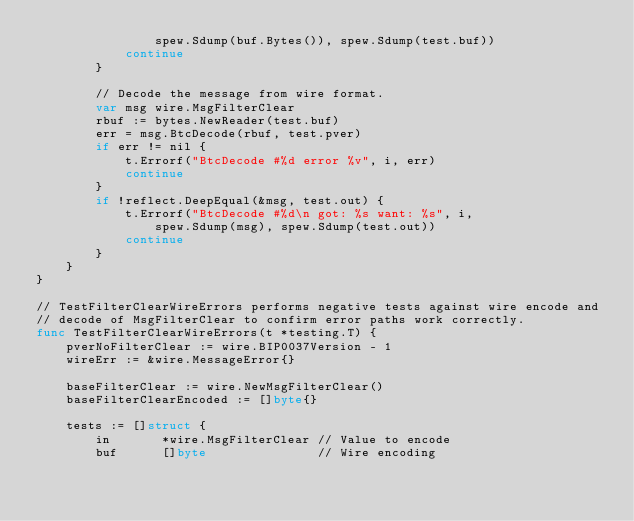Convert code to text. <code><loc_0><loc_0><loc_500><loc_500><_Go_>				spew.Sdump(buf.Bytes()), spew.Sdump(test.buf))
			continue
		}

		// Decode the message from wire format.
		var msg wire.MsgFilterClear
		rbuf := bytes.NewReader(test.buf)
		err = msg.BtcDecode(rbuf, test.pver)
		if err != nil {
			t.Errorf("BtcDecode #%d error %v", i, err)
			continue
		}
		if !reflect.DeepEqual(&msg, test.out) {
			t.Errorf("BtcDecode #%d\n got: %s want: %s", i,
				spew.Sdump(msg), spew.Sdump(test.out))
			continue
		}
	}
}

// TestFilterClearWireErrors performs negative tests against wire encode and
// decode of MsgFilterClear to confirm error paths work correctly.
func TestFilterClearWireErrors(t *testing.T) {
	pverNoFilterClear := wire.BIP0037Version - 1
	wireErr := &wire.MessageError{}

	baseFilterClear := wire.NewMsgFilterClear()
	baseFilterClearEncoded := []byte{}

	tests := []struct {
		in       *wire.MsgFilterClear // Value to encode
		buf      []byte               // Wire encoding</code> 